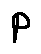<formula> <loc_0><loc_0><loc_500><loc_500>p</formula> 